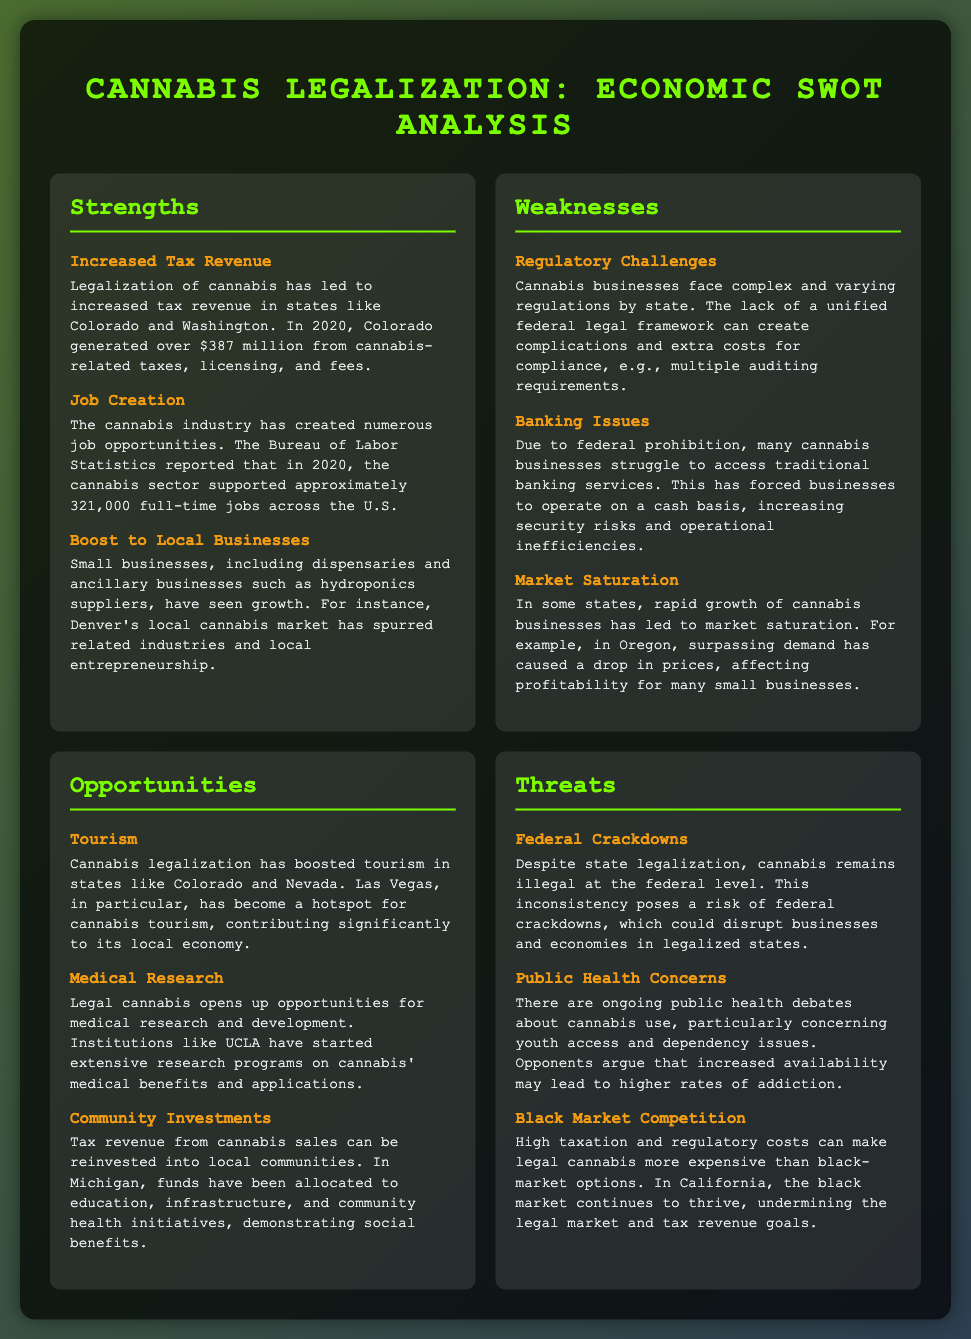what is Colorado's cannabis tax revenue in 2020? The document states that Colorado generated over $387 million from cannabis-related taxes in 2020.
Answer: $387 million how many full-time jobs did the cannabis sector support in 2020? According to the Bureau of Labor Statistics, the cannabis sector supported approximately 321,000 full-time jobs in 2020.
Answer: 321,000 what is a challenge faced by cannabis businesses according to the weaknesses section? The weaknesses section lists "Regulatory Challenges" as a significant issue faced by cannabis businesses.
Answer: Regulatory Challenges which state is mentioned as a hotspot for cannabis tourism? The document specifically mentions Las Vegas as a hotspot for cannabis tourism.
Answer: Las Vegas what can tax revenue from cannabis sales be reinvested into? The document mentions that tax revenue can be reinvested into local communities, including education, infrastructure, and community health initiatives.
Answer: local communities what is a threat posed by high taxation of legal cannabis? High taxation can make legal cannabis more expensive than black-market options, which is noted as a threat in the document.
Answer: black-market options what opportunity is associated with medical cannabis? The document states that legal cannabis opens up opportunities for medical research and development.
Answer: medical research what is a public health concern related to cannabis use? The document mentions "dependency issues" specifically as a public health concern related to cannabis use.
Answer: dependency issues 